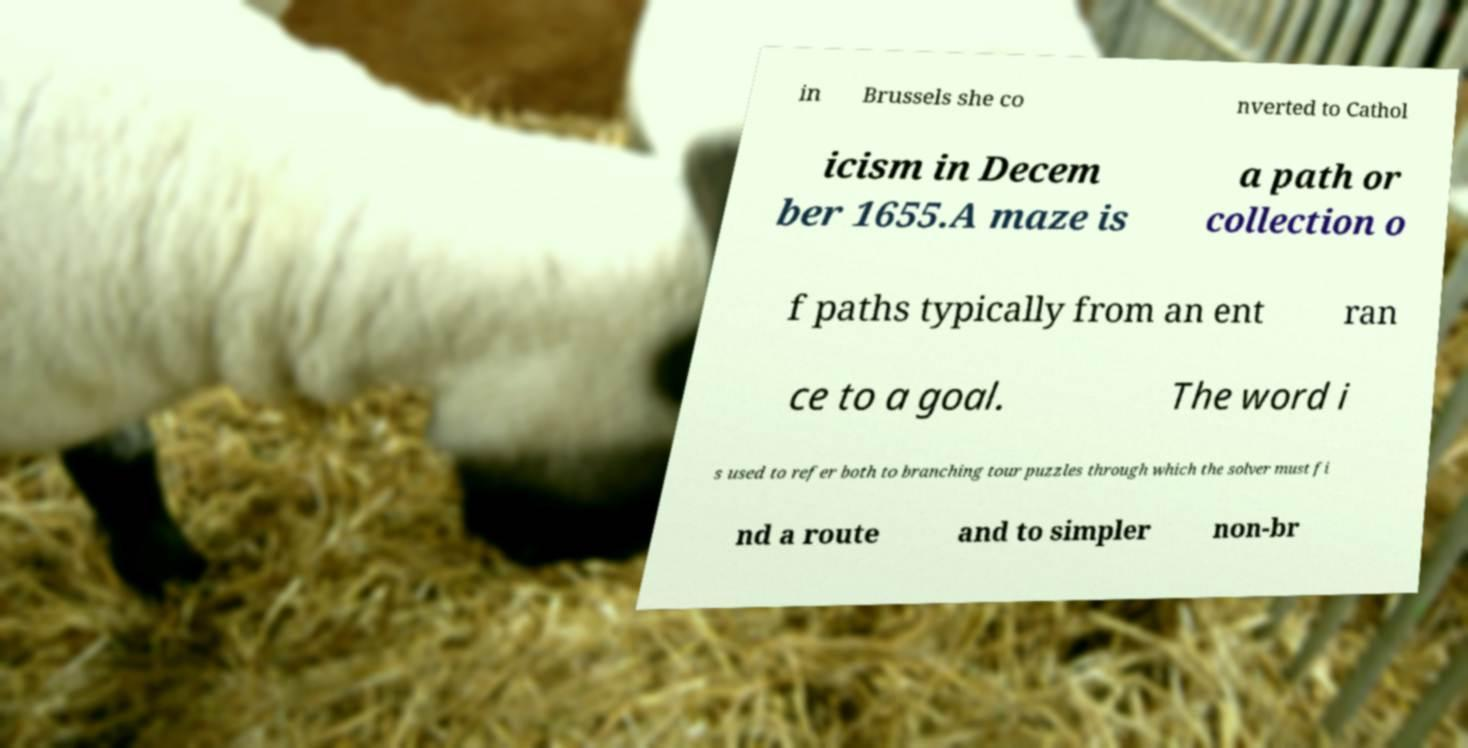What messages or text are displayed in this image? I need them in a readable, typed format. in Brussels she co nverted to Cathol icism in Decem ber 1655.A maze is a path or collection o f paths typically from an ent ran ce to a goal. The word i s used to refer both to branching tour puzzles through which the solver must fi nd a route and to simpler non-br 